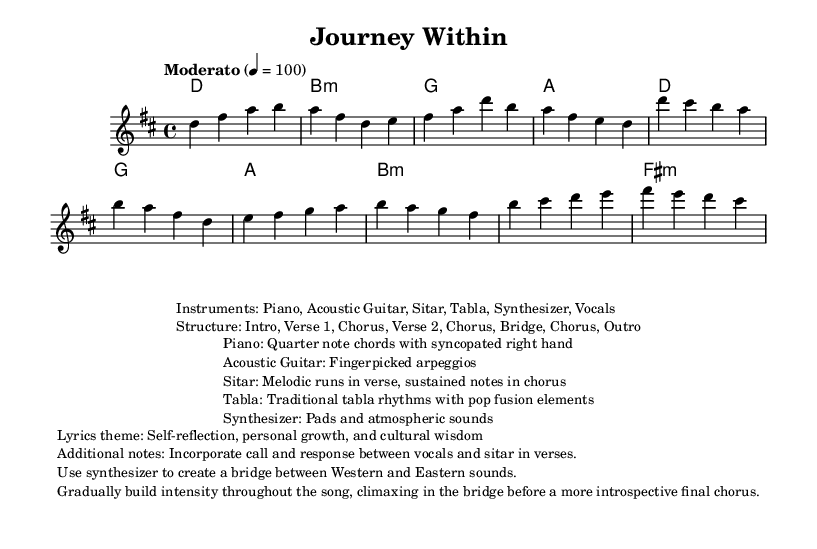What is the key signature of this music? The key signature is indicated in the global section, which shows "d \major," meaning the piece is in D major, which has two sharps (F# and C#).
Answer: D major What is the time signature? The time signature is found in the global section as "4/4," indicating that there are four beats in each measure, and the quarter note receives one beat.
Answer: 4/4 What is the tempo marking? The tempo marking is specified in the global section as "Moderato" and shows a metronome marking of 4 = 100, suggesting a moderate pace for the piece.
Answer: Moderato 4 = 100 What traditional instruments are used in this piece? The instruments are listed in the markdown section and include "Sitar" and "Tabla," which are traditional instruments from South Asian music that are incorporated into the fusion pop sound.
Answer: Sitar, Tabla What is the structure of the song? The structure is outlined in the markdown section and follows the order: "Intro, Verse 1, Chorus, Verse 2, Chorus, Bridge, Chorus, Outro," indicating how the song is organized.
Answer: Intro, Verse 1, Chorus, Verse 2, Chorus, Bridge, Chorus, Outro What themes are present in the lyrics of this song? The lyrics theme is provided in the markdown section and focuses on "Self-reflection, personal growth, and cultural wisdom," which suggests a deeper message and emotional journey in the song.
Answer: Self-reflection, personal growth, and cultural wisdom How do the instrumental elements contribute to the song's fusion style? The markdown section provides details on instrumental contributions, indicating that "traditional tabla rhythms with pop fusion elements" and "sustained notes in chorus" from the sitar blend various musical cultures, creating a unique sound.
Answer: Traditional tabla rhythms with pop fusion elements 